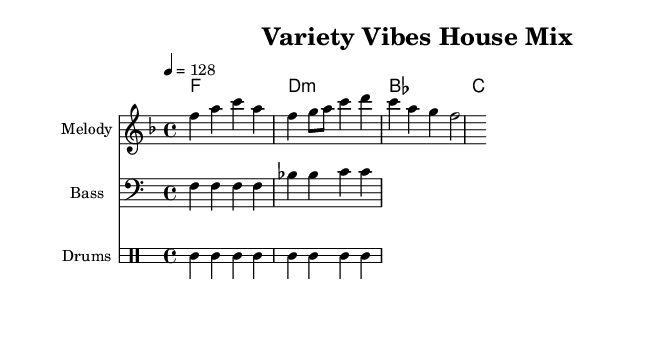What is the key signature of this music? The key signature is F major, which is identified by one flat (B flat) listed at the beginning of the staff.
Answer: F major What is the time signature of this music? The time signature is 4/4, indicated by the notation at the beginning of the score. This means there are four beats per measure, and the quarter note gets one beat.
Answer: 4/4 What is the tempo marking for this piece? The tempo marking is 128 beats per minute (bpm), indicated by the tempo indication "4 = 128" at the beginning of the score. This signifies the speed of the piece.
Answer: 128 How many measures are in the melody section? The melody section has three measures, which can be counted by looking at the separation of the notes and bars in the melody staff.
Answer: 3 What chord is used in the first measure of the harmony? The first measure of the harmony shows an F major chord, which corresponds to the root note F shown in the chord mode.
Answer: F What note does the bass play in the first measure? The bass plays the note F in the first measure, as indicated by the notation shown below the melody and harmony sections.
Answer: F What type of music is represented in this score? The music is House, identifiable by the upbeat tempo, rhythmic structure, and the presence of repetitive bass and drum patterns typical of the genre.
Answer: House 